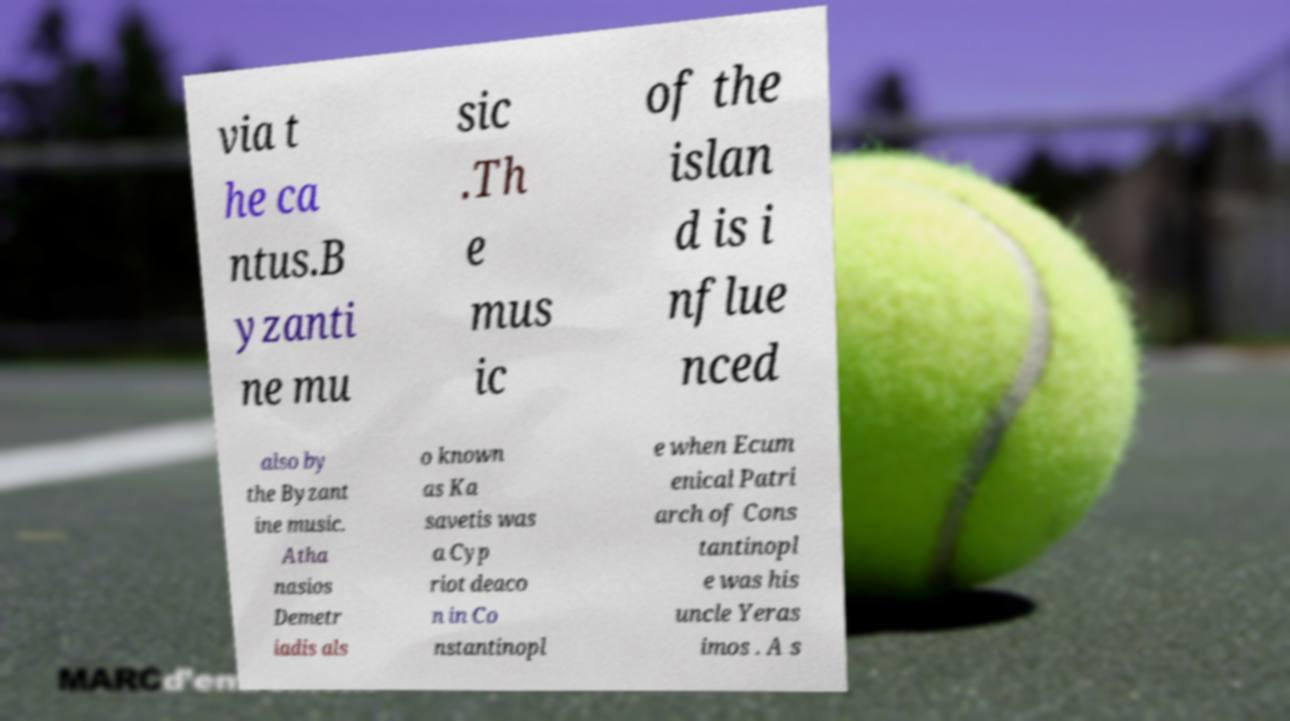Can you read and provide the text displayed in the image?This photo seems to have some interesting text. Can you extract and type it out for me? via t he ca ntus.B yzanti ne mu sic .Th e mus ic of the islan d is i nflue nced also by the Byzant ine music. Atha nasios Demetr iadis als o known as Ka savetis was a Cyp riot deaco n in Co nstantinopl e when Ecum enical Patri arch of Cons tantinopl e was his uncle Yeras imos . A s 